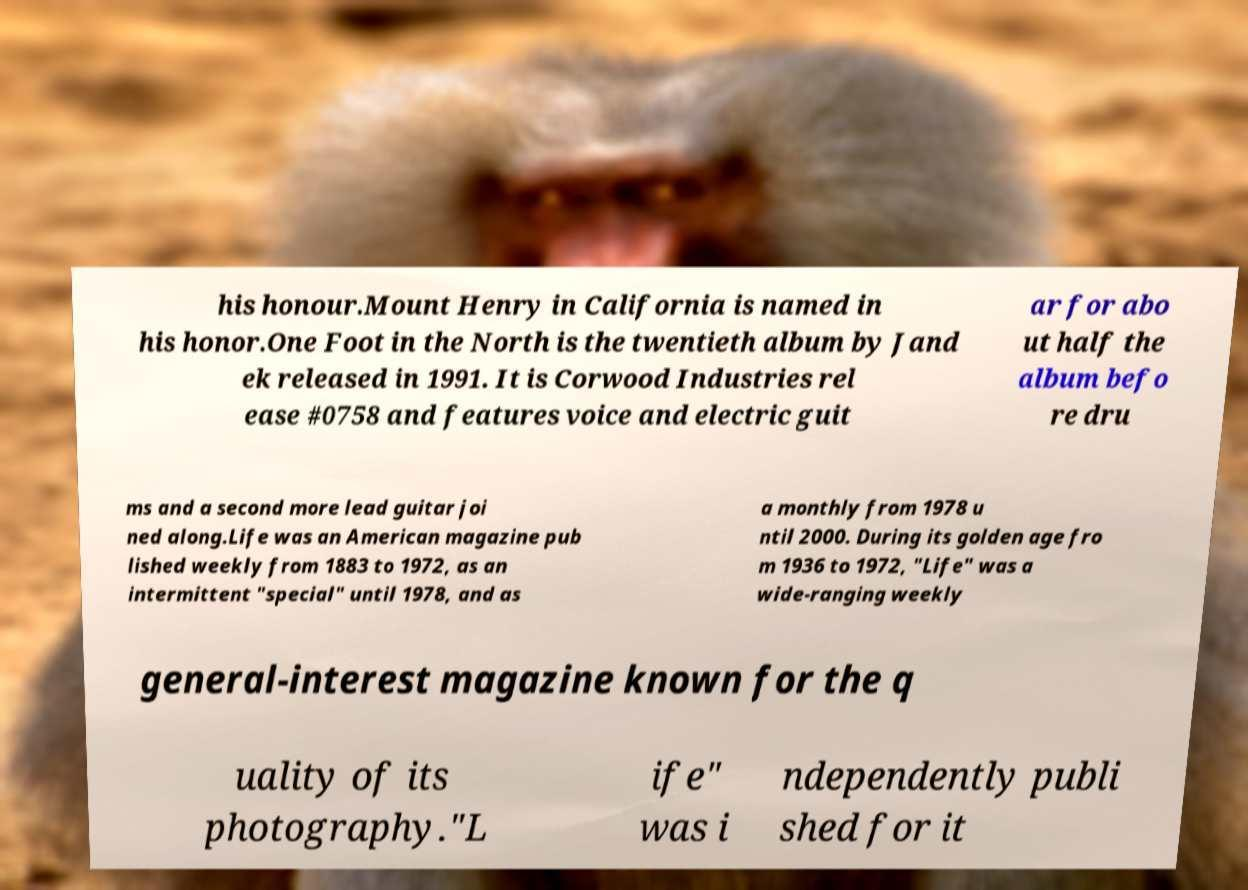Please identify and transcribe the text found in this image. his honour.Mount Henry in California is named in his honor.One Foot in the North is the twentieth album by Jand ek released in 1991. It is Corwood Industries rel ease #0758 and features voice and electric guit ar for abo ut half the album befo re dru ms and a second more lead guitar joi ned along.Life was an American magazine pub lished weekly from 1883 to 1972, as an intermittent "special" until 1978, and as a monthly from 1978 u ntil 2000. During its golden age fro m 1936 to 1972, "Life" was a wide-ranging weekly general-interest magazine known for the q uality of its photography."L ife" was i ndependently publi shed for it 